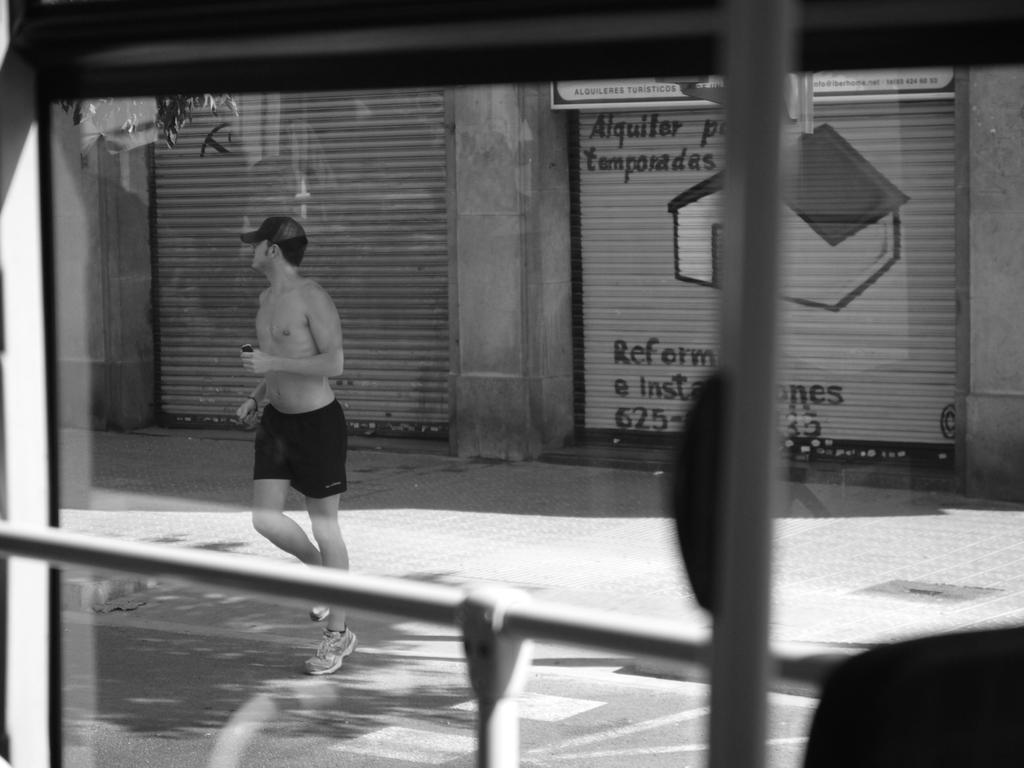What is the color scheme of the image? The image is black and white. What objects can be seen in the image? There are iron rods in the image. What is happening in the background of the image? There is a man walking in the background of the image, and he is walking on a road. What type of establishments can be seen in the background of the image? There are shops in the background of the image. What type of tramp is visible in the image? There is no tramp present in the image. What system is responsible for the man walking in the image? The image does not provide information about a system responsible for the man walking; he is simply walking on a road. 